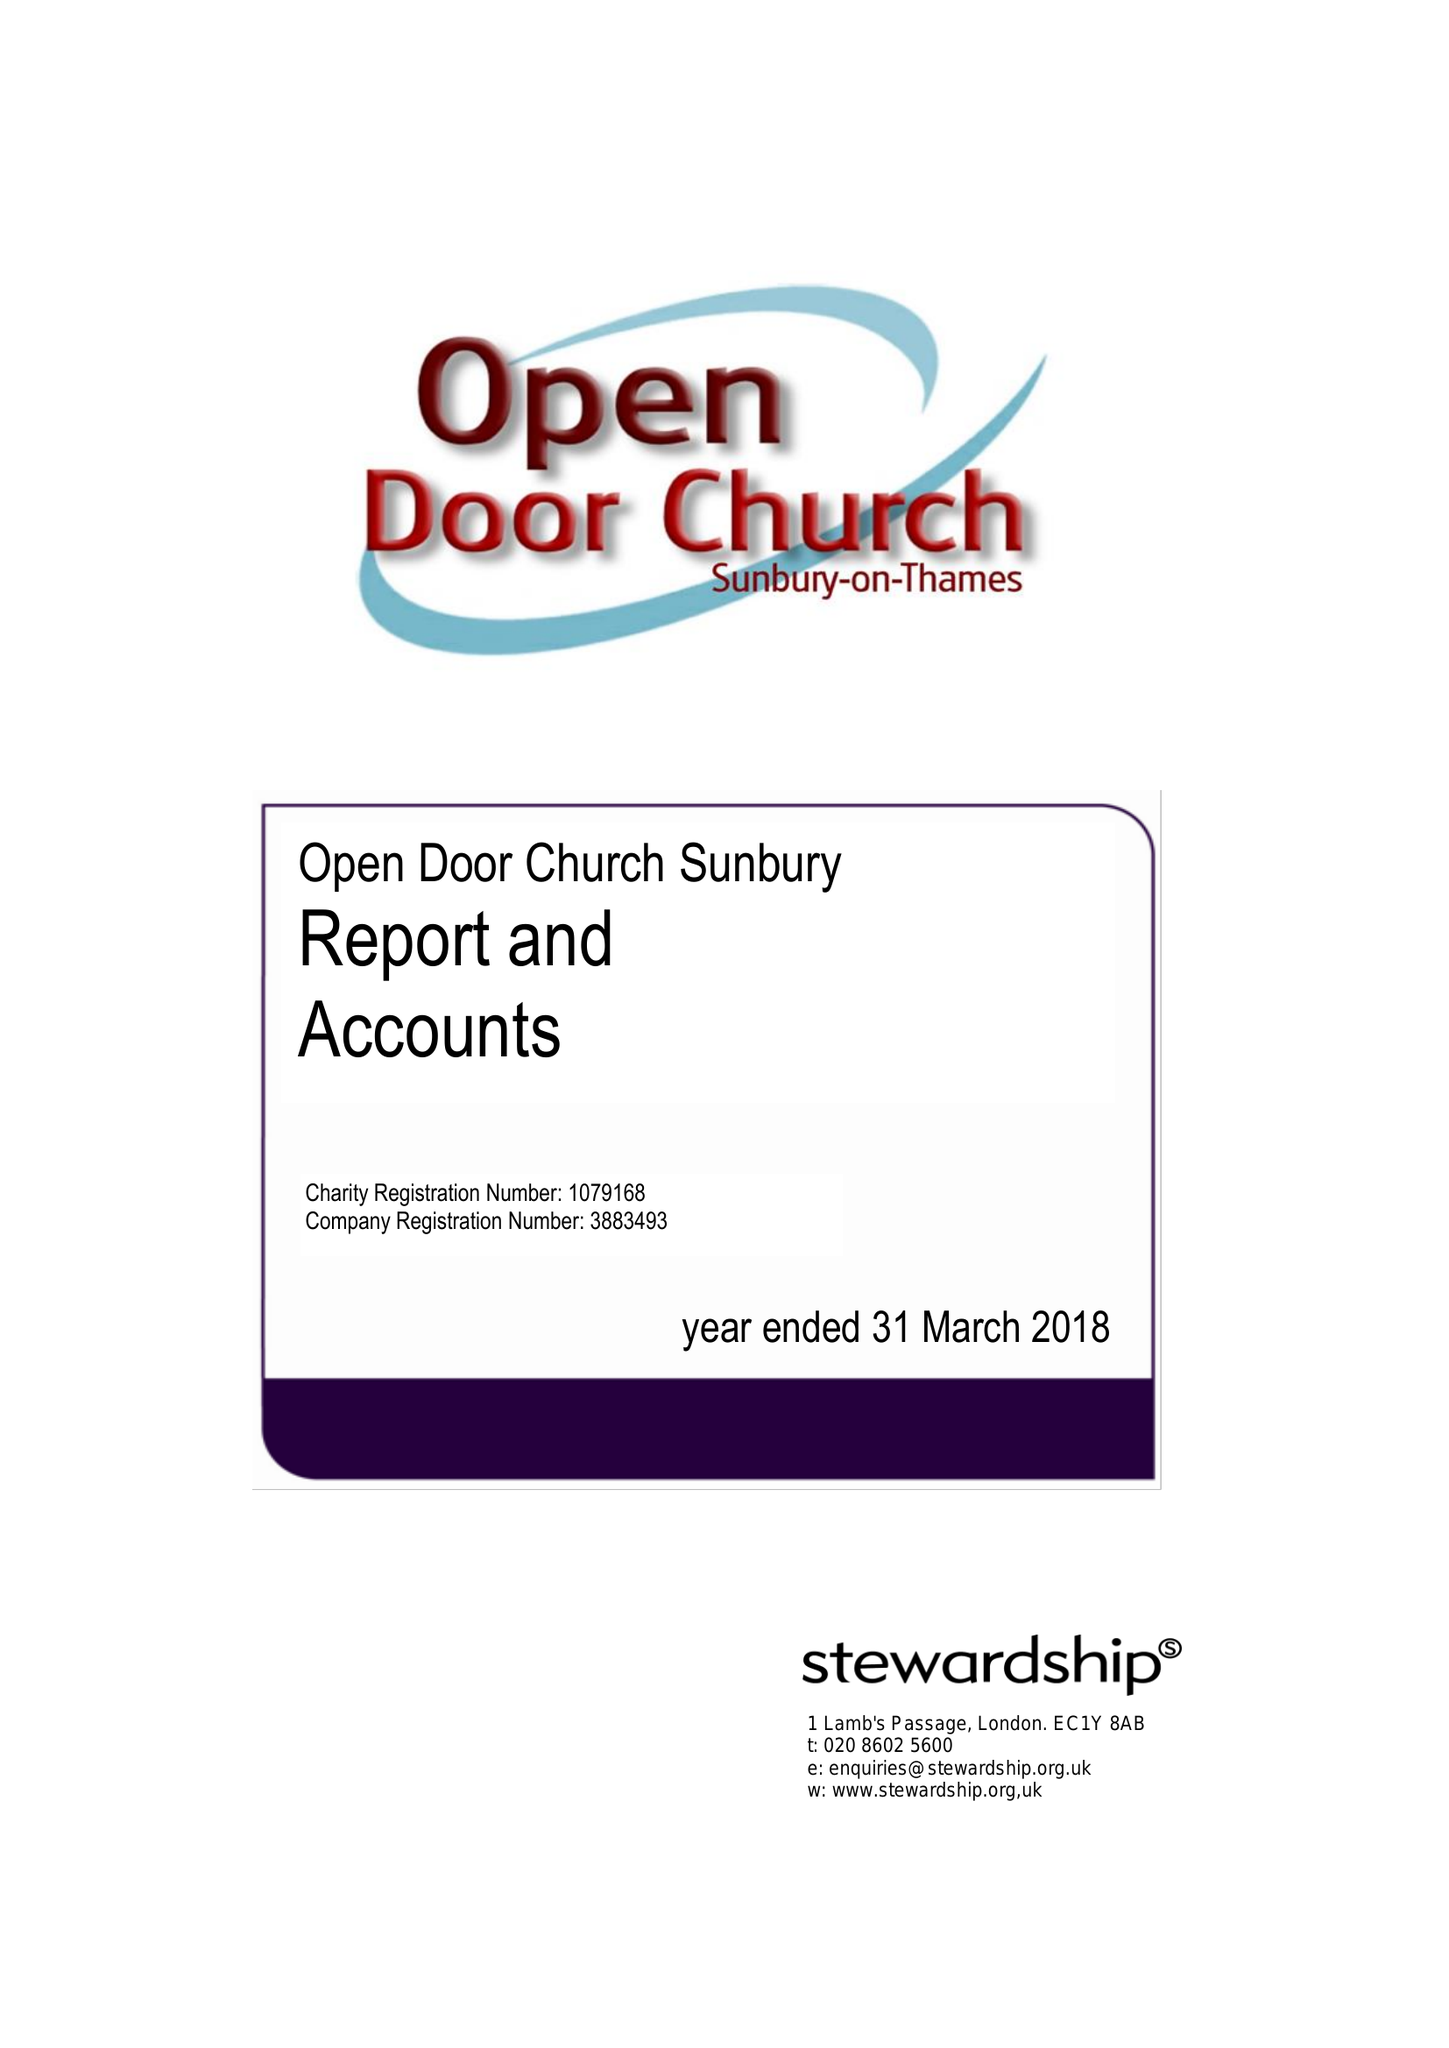What is the value for the address__street_line?
Answer the question using a single word or phrase. GREEN STREET 